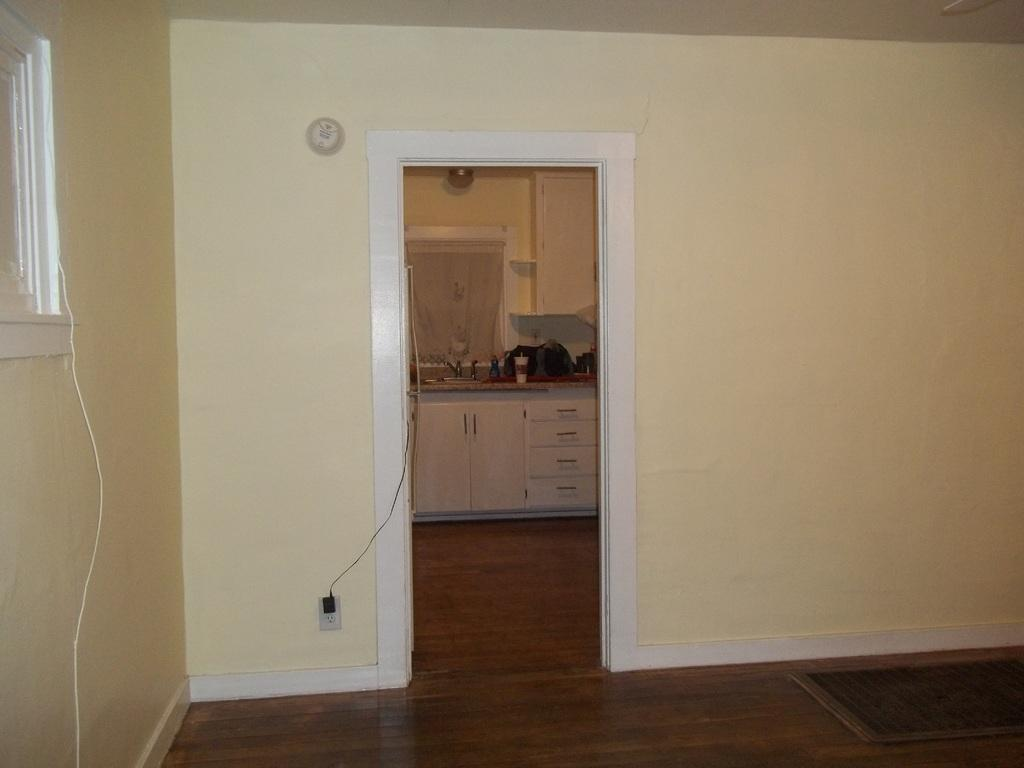Where was the image taken? The image was taken in a room. What can be seen in the front of the room? There is a kitchen in the front of the room. What part of the room is visible at the bottom of the image? The floor is visible at the bottom of the image. What type of architectural feature is present in the walls? A window is present in the walls. What type of impulse can be seen affecting the window in the image? There is no impulse affecting the window in the image; it is stationary and not moving. Can you see an umbrella being used in the kitchen in the image? There is no umbrella present in the kitchen or any other part of the image. 